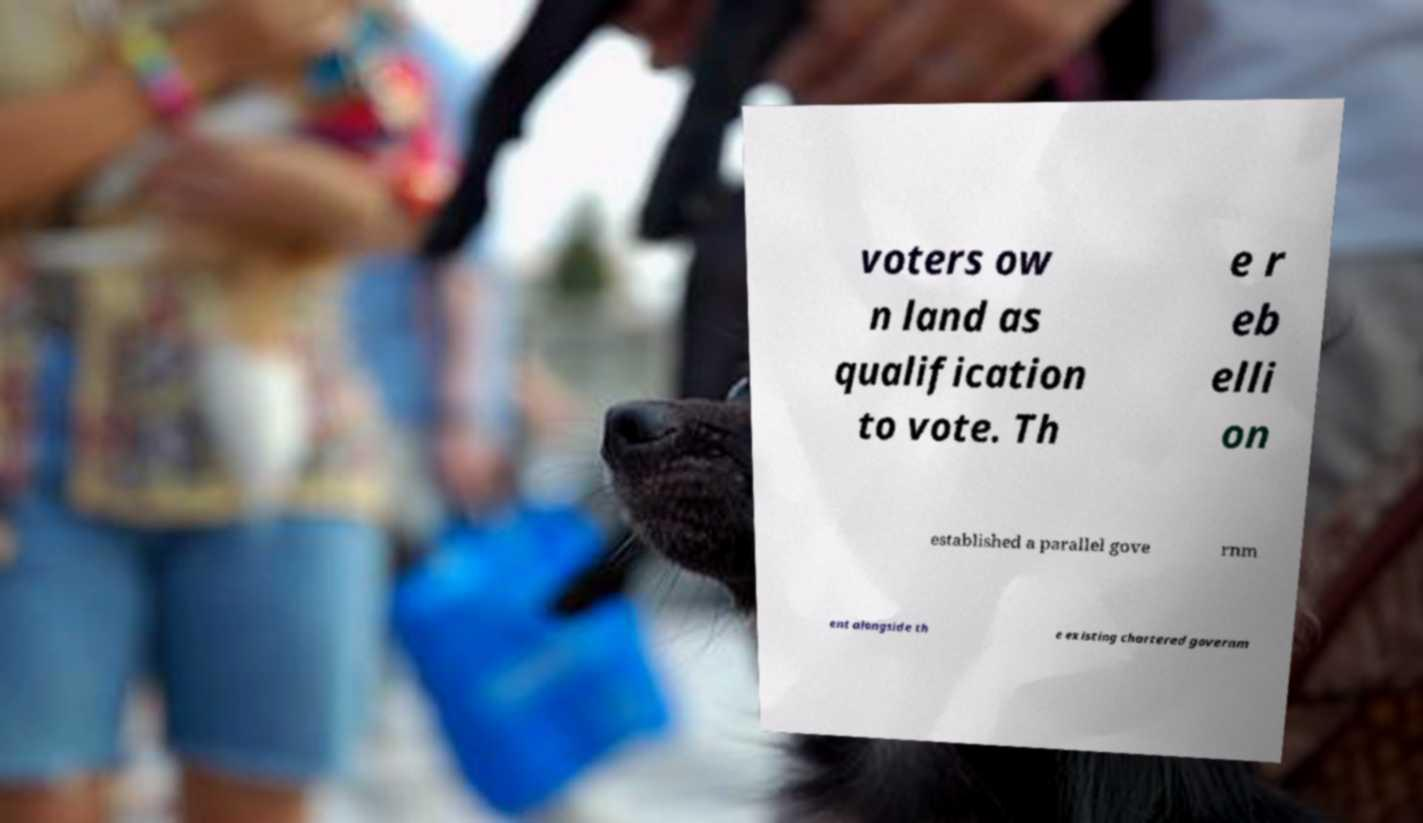Please identify and transcribe the text found in this image. voters ow n land as qualification to vote. Th e r eb elli on established a parallel gove rnm ent alongside th e existing chartered governm 